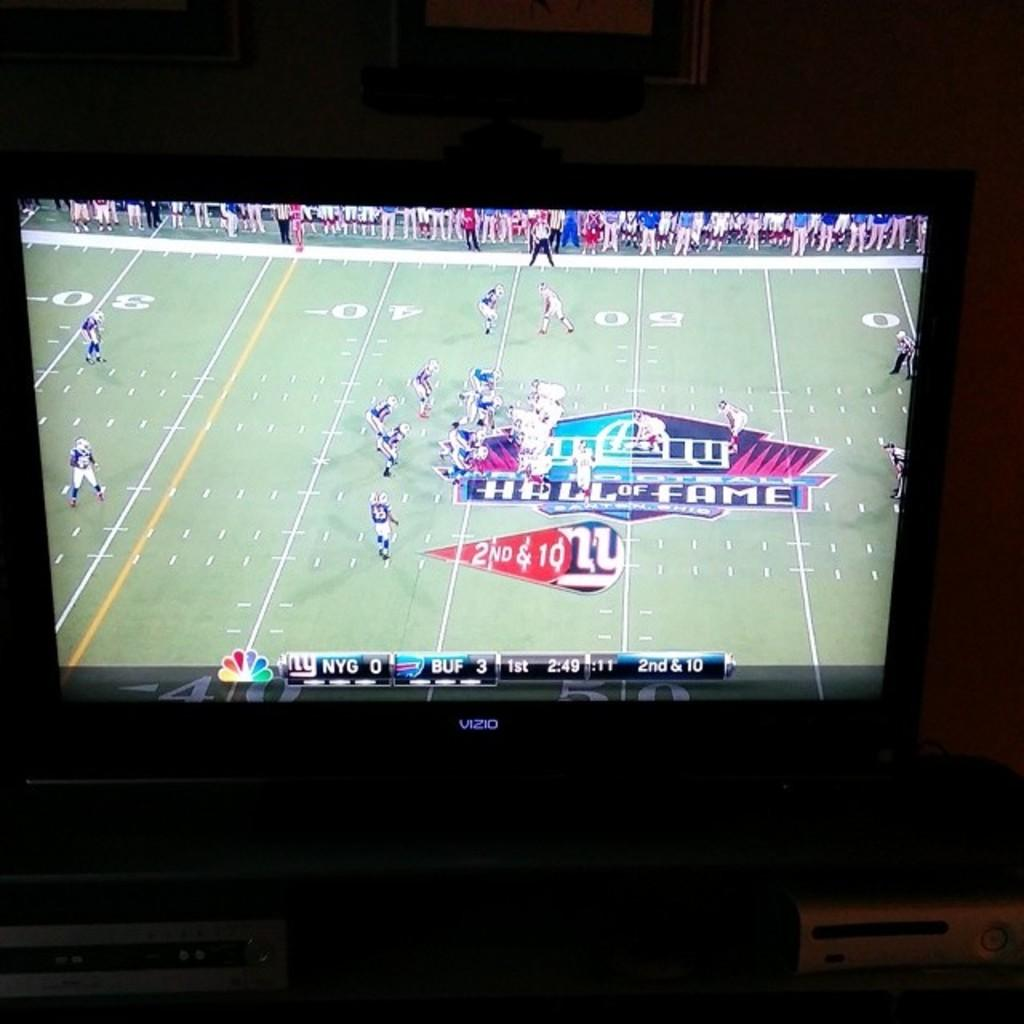<image>
Offer a succinct explanation of the picture presented. Buffalo leads the Giants 3-0 in the first quarter of the football game on television. 